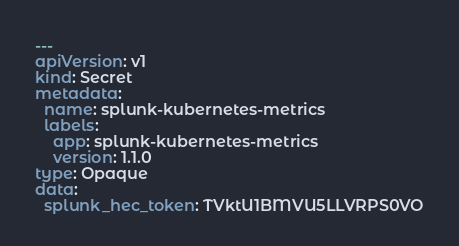<code> <loc_0><loc_0><loc_500><loc_500><_YAML_>---
apiVersion: v1
kind: Secret
metadata:
  name: splunk-kubernetes-metrics
  labels:
    app: splunk-kubernetes-metrics
    version: 1.1.0
type: Opaque
data:
  splunk_hec_token: TVktU1BMVU5LLVRPS0VO
</code> 